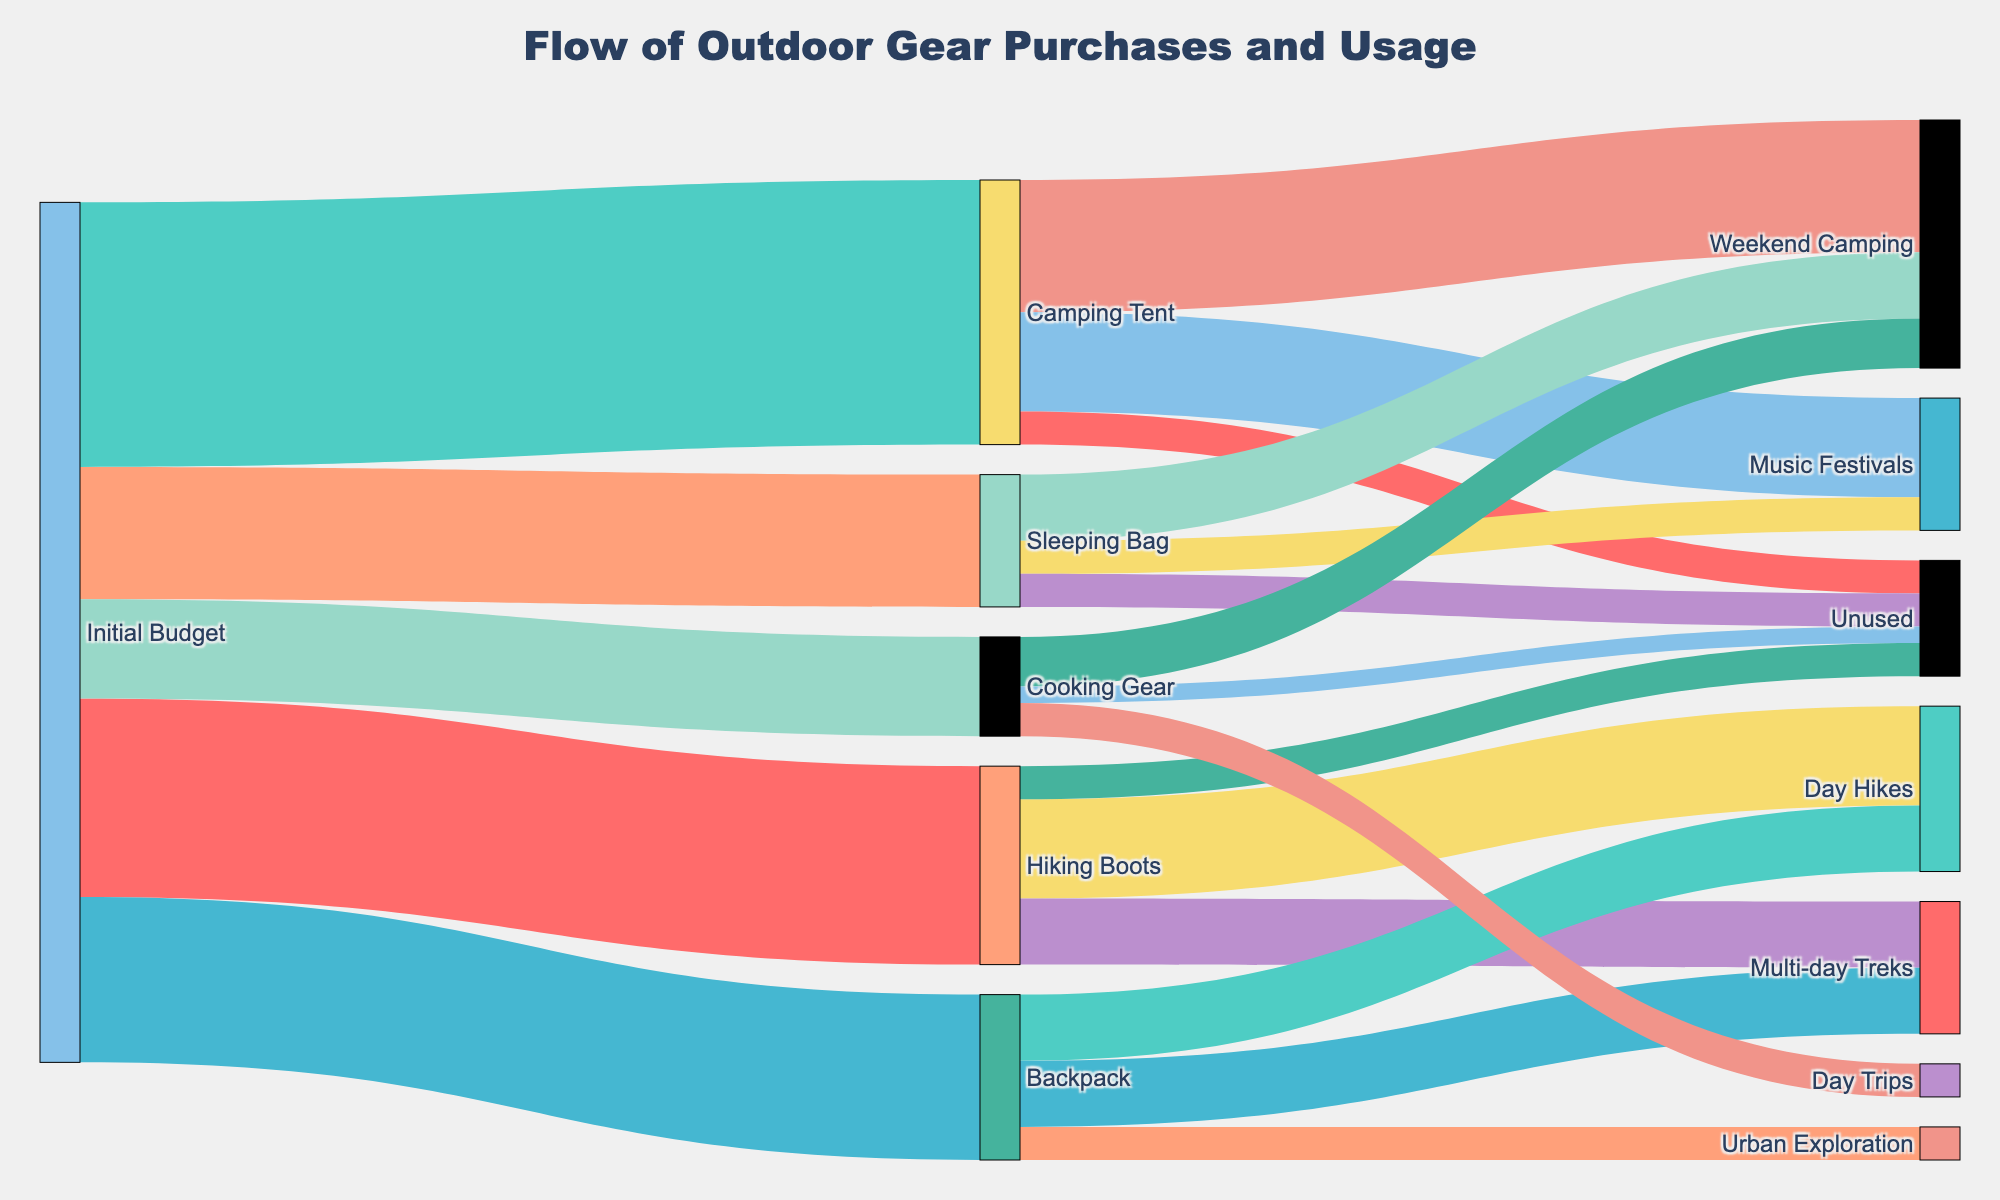What's the title of the figure? The title of the figure is displayed at the top, summarizing the main content of the Sankey Diagram. It reads "Flow of Outdoor Gear Purchases and Usage"
Answer: Flow of Outdoor Gear Purchases and Usage Which gear had the highest initial budget allocation? To find this, look at the initial budget allocations flowing into different gears. The gear with the thickest flow from "Initial Budget" represents the highest allocation. Camping Tent receives 400, which is the highest value among the gears.
Answer: Camping Tent How much of the budget was allocated to Day Hikes from both Backpack and Hiking Boots combined? Adding the amounts flowing into Day Hikes from both gears: Hiking Boots contribute 150, and Backpack contributes 100. Thus, 150 + 100 = 250.
Answer: 250 Which gear has the most unused budget? Look for the flows labeled "Unused" from each gear. Compare the values for Hiking Boots (50), Camping Tent (50), Backpack (none), Sleeping Bag (50), and Cooking Gear (25). Hiking Boots, Camping Tent, and Sleeping Bag all have the same highest value of 50.
Answer: Hiking Boots, Camping Tent, and Sleeping Bag Which usage activity received the least budget from all gear combined? Summing up the budget from each gear for each activity: Day Hikes (150+100=250), Multi-day Treks (100+100=200), Unused (50+50+50+25=175), Weekend Camping (200+100+75=375), Music Festivals (150+50=200), Urban Exploration (50), Day Trips (50). Urban Exploration and Day Trips both have the lowest, with 50 each.
Answer: Urban Exploration and Day Trips What's the total initial budget considered in the figure? Summing up the initial budget allocations: Hiking Boots (300), Camping Tent (400), Backpack (250), Sleeping Bag (200), Cooking Gear (150). Thus, 300 + 400 + 250 + 200 + 150 = 1300.
Answer: 1300 